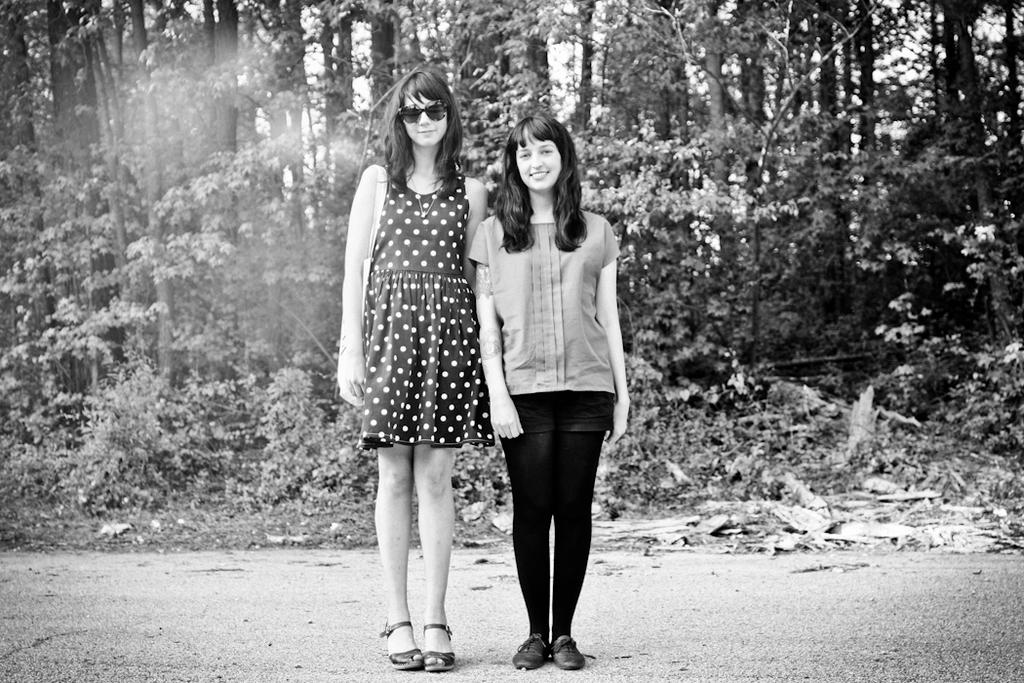How many people are in the image? There are two women in the image. What are the women doing in the image? The women are standing in the middle of the image and smiling. What can be seen in the background of the image? There are trees visible behind the women. What type of corn is being harvested by the women in the image? There is no corn present in the image; the women are simply standing and smiling. 